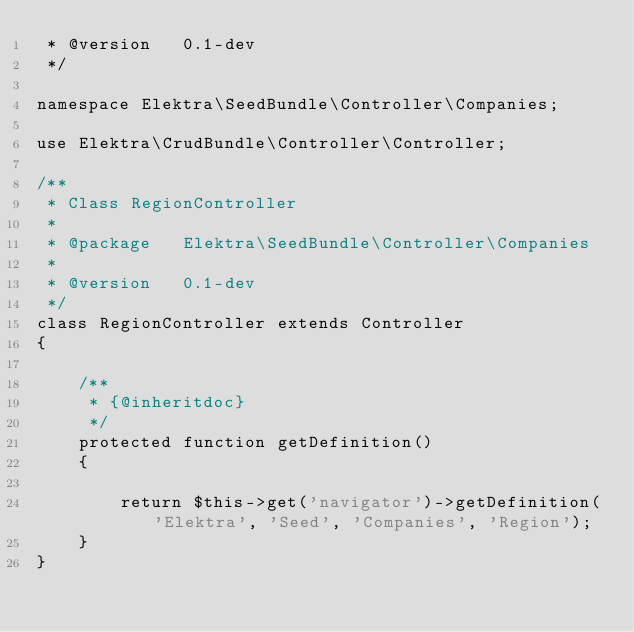Convert code to text. <code><loc_0><loc_0><loc_500><loc_500><_PHP_> * @version   0.1-dev
 */

namespace Elektra\SeedBundle\Controller\Companies;

use Elektra\CrudBundle\Controller\Controller;

/**
 * Class RegionController
 *
 * @package   Elektra\SeedBundle\Controller\Companies
 *
 * @version   0.1-dev
 */
class RegionController extends Controller
{

    /**
     * {@inheritdoc}
     */
    protected function getDefinition()
    {

        return $this->get('navigator')->getDefinition('Elektra', 'Seed', 'Companies', 'Region');
    }
}</code> 